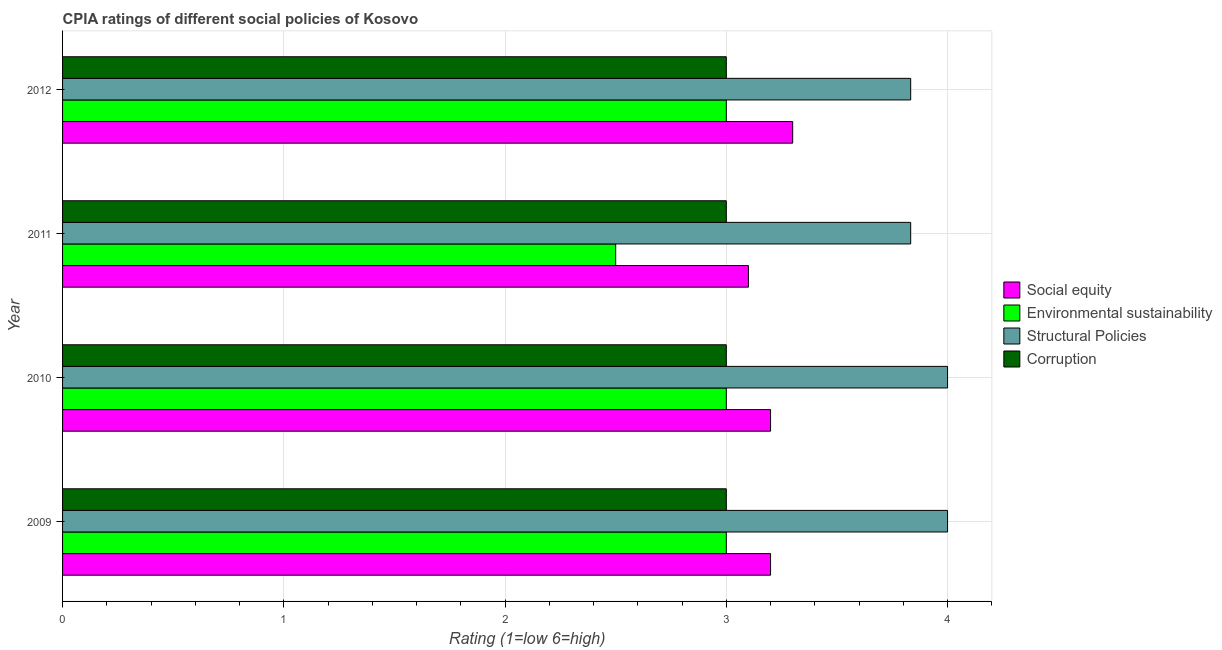How many different coloured bars are there?
Make the answer very short. 4. How many groups of bars are there?
Provide a short and direct response. 4. Are the number of bars on each tick of the Y-axis equal?
Ensure brevity in your answer.  Yes. How many bars are there on the 1st tick from the top?
Give a very brief answer. 4. What is the label of the 1st group of bars from the top?
Give a very brief answer. 2012. In how many cases, is the number of bars for a given year not equal to the number of legend labels?
Ensure brevity in your answer.  0. In which year was the cpia rating of corruption maximum?
Ensure brevity in your answer.  2009. In which year was the cpia rating of corruption minimum?
Keep it short and to the point. 2009. What is the total cpia rating of structural policies in the graph?
Your answer should be compact. 15.67. What is the difference between the cpia rating of corruption in 2010 and the cpia rating of social equity in 2011?
Give a very brief answer. -0.1. What is the average cpia rating of environmental sustainability per year?
Offer a terse response. 2.88. In the year 2012, what is the difference between the cpia rating of corruption and cpia rating of social equity?
Your answer should be compact. -0.3. In how many years, is the cpia rating of environmental sustainability greater than 0.6000000000000001 ?
Make the answer very short. 4. What is the ratio of the cpia rating of social equity in 2010 to that in 2011?
Make the answer very short. 1.03. Is the cpia rating of social equity in 2011 less than that in 2012?
Provide a short and direct response. Yes. Is the difference between the cpia rating of social equity in 2011 and 2012 greater than the difference between the cpia rating of environmental sustainability in 2011 and 2012?
Your answer should be compact. Yes. What is the difference between the highest and the lowest cpia rating of social equity?
Your response must be concise. 0.2. In how many years, is the cpia rating of environmental sustainability greater than the average cpia rating of environmental sustainability taken over all years?
Make the answer very short. 3. Is the sum of the cpia rating of environmental sustainability in 2010 and 2011 greater than the maximum cpia rating of social equity across all years?
Your answer should be compact. Yes. Is it the case that in every year, the sum of the cpia rating of environmental sustainability and cpia rating of corruption is greater than the sum of cpia rating of structural policies and cpia rating of social equity?
Make the answer very short. No. What does the 1st bar from the top in 2009 represents?
Offer a terse response. Corruption. What does the 1st bar from the bottom in 2010 represents?
Provide a short and direct response. Social equity. How many bars are there?
Provide a succinct answer. 16. How many years are there in the graph?
Provide a succinct answer. 4. What is the difference between two consecutive major ticks on the X-axis?
Your response must be concise. 1. Does the graph contain any zero values?
Give a very brief answer. No. Does the graph contain grids?
Ensure brevity in your answer.  Yes. How are the legend labels stacked?
Give a very brief answer. Vertical. What is the title of the graph?
Keep it short and to the point. CPIA ratings of different social policies of Kosovo. Does "UNAIDS" appear as one of the legend labels in the graph?
Your response must be concise. No. What is the Rating (1=low 6=high) in Environmental sustainability in 2009?
Give a very brief answer. 3. What is the Rating (1=low 6=high) of Structural Policies in 2009?
Provide a succinct answer. 4. What is the Rating (1=low 6=high) in Environmental sustainability in 2011?
Provide a short and direct response. 2.5. What is the Rating (1=low 6=high) of Structural Policies in 2011?
Provide a succinct answer. 3.83. What is the Rating (1=low 6=high) of Social equity in 2012?
Give a very brief answer. 3.3. What is the Rating (1=low 6=high) of Environmental sustainability in 2012?
Offer a very short reply. 3. What is the Rating (1=low 6=high) in Structural Policies in 2012?
Make the answer very short. 3.83. Across all years, what is the maximum Rating (1=low 6=high) of Social equity?
Your answer should be compact. 3.3. Across all years, what is the maximum Rating (1=low 6=high) of Environmental sustainability?
Offer a very short reply. 3. Across all years, what is the maximum Rating (1=low 6=high) of Structural Policies?
Offer a very short reply. 4. Across all years, what is the minimum Rating (1=low 6=high) of Environmental sustainability?
Ensure brevity in your answer.  2.5. Across all years, what is the minimum Rating (1=low 6=high) of Structural Policies?
Your response must be concise. 3.83. What is the total Rating (1=low 6=high) of Social equity in the graph?
Offer a terse response. 12.8. What is the total Rating (1=low 6=high) in Environmental sustainability in the graph?
Your response must be concise. 11.5. What is the total Rating (1=low 6=high) of Structural Policies in the graph?
Your response must be concise. 15.67. What is the total Rating (1=low 6=high) of Corruption in the graph?
Your answer should be compact. 12. What is the difference between the Rating (1=low 6=high) in Corruption in 2009 and that in 2011?
Keep it short and to the point. 0. What is the difference between the Rating (1=low 6=high) in Social equity in 2009 and that in 2012?
Make the answer very short. -0.1. What is the difference between the Rating (1=low 6=high) in Structural Policies in 2009 and that in 2012?
Provide a succinct answer. 0.17. What is the difference between the Rating (1=low 6=high) of Social equity in 2010 and that in 2011?
Give a very brief answer. 0.1. What is the difference between the Rating (1=low 6=high) of Structural Policies in 2010 and that in 2011?
Offer a terse response. 0.17. What is the difference between the Rating (1=low 6=high) of Corruption in 2010 and that in 2011?
Provide a short and direct response. 0. What is the difference between the Rating (1=low 6=high) of Environmental sustainability in 2010 and that in 2012?
Keep it short and to the point. 0. What is the difference between the Rating (1=low 6=high) in Social equity in 2011 and that in 2012?
Your answer should be very brief. -0.2. What is the difference between the Rating (1=low 6=high) of Social equity in 2009 and the Rating (1=low 6=high) of Structural Policies in 2010?
Provide a short and direct response. -0.8. What is the difference between the Rating (1=low 6=high) in Social equity in 2009 and the Rating (1=low 6=high) in Corruption in 2010?
Offer a terse response. 0.2. What is the difference between the Rating (1=low 6=high) of Environmental sustainability in 2009 and the Rating (1=low 6=high) of Structural Policies in 2010?
Offer a very short reply. -1. What is the difference between the Rating (1=low 6=high) in Environmental sustainability in 2009 and the Rating (1=low 6=high) in Corruption in 2010?
Offer a very short reply. 0. What is the difference between the Rating (1=low 6=high) in Structural Policies in 2009 and the Rating (1=low 6=high) in Corruption in 2010?
Provide a short and direct response. 1. What is the difference between the Rating (1=low 6=high) of Social equity in 2009 and the Rating (1=low 6=high) of Structural Policies in 2011?
Give a very brief answer. -0.63. What is the difference between the Rating (1=low 6=high) of Social equity in 2009 and the Rating (1=low 6=high) of Corruption in 2011?
Your answer should be very brief. 0.2. What is the difference between the Rating (1=low 6=high) in Environmental sustainability in 2009 and the Rating (1=low 6=high) in Corruption in 2011?
Offer a very short reply. 0. What is the difference between the Rating (1=low 6=high) of Social equity in 2009 and the Rating (1=low 6=high) of Structural Policies in 2012?
Ensure brevity in your answer.  -0.63. What is the difference between the Rating (1=low 6=high) in Environmental sustainability in 2009 and the Rating (1=low 6=high) in Structural Policies in 2012?
Offer a very short reply. -0.83. What is the difference between the Rating (1=low 6=high) of Social equity in 2010 and the Rating (1=low 6=high) of Structural Policies in 2011?
Provide a succinct answer. -0.63. What is the difference between the Rating (1=low 6=high) in Environmental sustainability in 2010 and the Rating (1=low 6=high) in Structural Policies in 2011?
Make the answer very short. -0.83. What is the difference between the Rating (1=low 6=high) in Structural Policies in 2010 and the Rating (1=low 6=high) in Corruption in 2011?
Your answer should be compact. 1. What is the difference between the Rating (1=low 6=high) in Social equity in 2010 and the Rating (1=low 6=high) in Structural Policies in 2012?
Give a very brief answer. -0.63. What is the difference between the Rating (1=low 6=high) in Social equity in 2010 and the Rating (1=low 6=high) in Corruption in 2012?
Provide a succinct answer. 0.2. What is the difference between the Rating (1=low 6=high) in Environmental sustainability in 2010 and the Rating (1=low 6=high) in Corruption in 2012?
Your answer should be compact. 0. What is the difference between the Rating (1=low 6=high) in Social equity in 2011 and the Rating (1=low 6=high) in Structural Policies in 2012?
Give a very brief answer. -0.73. What is the difference between the Rating (1=low 6=high) in Environmental sustainability in 2011 and the Rating (1=low 6=high) in Structural Policies in 2012?
Provide a succinct answer. -1.33. What is the difference between the Rating (1=low 6=high) of Environmental sustainability in 2011 and the Rating (1=low 6=high) of Corruption in 2012?
Your answer should be very brief. -0.5. What is the average Rating (1=low 6=high) of Social equity per year?
Keep it short and to the point. 3.2. What is the average Rating (1=low 6=high) of Environmental sustainability per year?
Your answer should be compact. 2.88. What is the average Rating (1=low 6=high) of Structural Policies per year?
Provide a short and direct response. 3.92. In the year 2009, what is the difference between the Rating (1=low 6=high) of Social equity and Rating (1=low 6=high) of Environmental sustainability?
Give a very brief answer. 0.2. In the year 2009, what is the difference between the Rating (1=low 6=high) of Social equity and Rating (1=low 6=high) of Structural Policies?
Your response must be concise. -0.8. In the year 2009, what is the difference between the Rating (1=low 6=high) of Environmental sustainability and Rating (1=low 6=high) of Structural Policies?
Your answer should be very brief. -1. In the year 2009, what is the difference between the Rating (1=low 6=high) in Environmental sustainability and Rating (1=low 6=high) in Corruption?
Keep it short and to the point. 0. In the year 2010, what is the difference between the Rating (1=low 6=high) in Social equity and Rating (1=low 6=high) in Environmental sustainability?
Offer a very short reply. 0.2. In the year 2011, what is the difference between the Rating (1=low 6=high) of Social equity and Rating (1=low 6=high) of Environmental sustainability?
Give a very brief answer. 0.6. In the year 2011, what is the difference between the Rating (1=low 6=high) of Social equity and Rating (1=low 6=high) of Structural Policies?
Provide a succinct answer. -0.73. In the year 2011, what is the difference between the Rating (1=low 6=high) in Social equity and Rating (1=low 6=high) in Corruption?
Make the answer very short. 0.1. In the year 2011, what is the difference between the Rating (1=low 6=high) of Environmental sustainability and Rating (1=low 6=high) of Structural Policies?
Offer a very short reply. -1.33. In the year 2011, what is the difference between the Rating (1=low 6=high) of Environmental sustainability and Rating (1=low 6=high) of Corruption?
Ensure brevity in your answer.  -0.5. In the year 2011, what is the difference between the Rating (1=low 6=high) of Structural Policies and Rating (1=low 6=high) of Corruption?
Your answer should be compact. 0.83. In the year 2012, what is the difference between the Rating (1=low 6=high) of Social equity and Rating (1=low 6=high) of Environmental sustainability?
Keep it short and to the point. 0.3. In the year 2012, what is the difference between the Rating (1=low 6=high) in Social equity and Rating (1=low 6=high) in Structural Policies?
Offer a very short reply. -0.53. In the year 2012, what is the difference between the Rating (1=low 6=high) of Environmental sustainability and Rating (1=low 6=high) of Structural Policies?
Offer a very short reply. -0.83. In the year 2012, what is the difference between the Rating (1=low 6=high) in Environmental sustainability and Rating (1=low 6=high) in Corruption?
Ensure brevity in your answer.  0. In the year 2012, what is the difference between the Rating (1=low 6=high) in Structural Policies and Rating (1=low 6=high) in Corruption?
Your answer should be very brief. 0.83. What is the ratio of the Rating (1=low 6=high) of Social equity in 2009 to that in 2010?
Keep it short and to the point. 1. What is the ratio of the Rating (1=low 6=high) in Social equity in 2009 to that in 2011?
Provide a succinct answer. 1.03. What is the ratio of the Rating (1=low 6=high) of Environmental sustainability in 2009 to that in 2011?
Provide a succinct answer. 1.2. What is the ratio of the Rating (1=low 6=high) in Structural Policies in 2009 to that in 2011?
Your response must be concise. 1.04. What is the ratio of the Rating (1=low 6=high) in Corruption in 2009 to that in 2011?
Keep it short and to the point. 1. What is the ratio of the Rating (1=low 6=high) in Social equity in 2009 to that in 2012?
Make the answer very short. 0.97. What is the ratio of the Rating (1=low 6=high) in Structural Policies in 2009 to that in 2012?
Your response must be concise. 1.04. What is the ratio of the Rating (1=low 6=high) of Social equity in 2010 to that in 2011?
Provide a short and direct response. 1.03. What is the ratio of the Rating (1=low 6=high) in Environmental sustainability in 2010 to that in 2011?
Provide a succinct answer. 1.2. What is the ratio of the Rating (1=low 6=high) of Structural Policies in 2010 to that in 2011?
Make the answer very short. 1.04. What is the ratio of the Rating (1=low 6=high) in Social equity in 2010 to that in 2012?
Give a very brief answer. 0.97. What is the ratio of the Rating (1=low 6=high) in Structural Policies in 2010 to that in 2012?
Keep it short and to the point. 1.04. What is the ratio of the Rating (1=low 6=high) of Corruption in 2010 to that in 2012?
Keep it short and to the point. 1. What is the ratio of the Rating (1=low 6=high) in Social equity in 2011 to that in 2012?
Give a very brief answer. 0.94. What is the ratio of the Rating (1=low 6=high) of Environmental sustainability in 2011 to that in 2012?
Ensure brevity in your answer.  0.83. What is the ratio of the Rating (1=low 6=high) of Corruption in 2011 to that in 2012?
Offer a very short reply. 1. What is the difference between the highest and the second highest Rating (1=low 6=high) in Social equity?
Ensure brevity in your answer.  0.1. What is the difference between the highest and the second highest Rating (1=low 6=high) of Structural Policies?
Offer a terse response. 0. What is the difference between the highest and the second highest Rating (1=low 6=high) of Corruption?
Give a very brief answer. 0. What is the difference between the highest and the lowest Rating (1=low 6=high) of Social equity?
Provide a succinct answer. 0.2. 